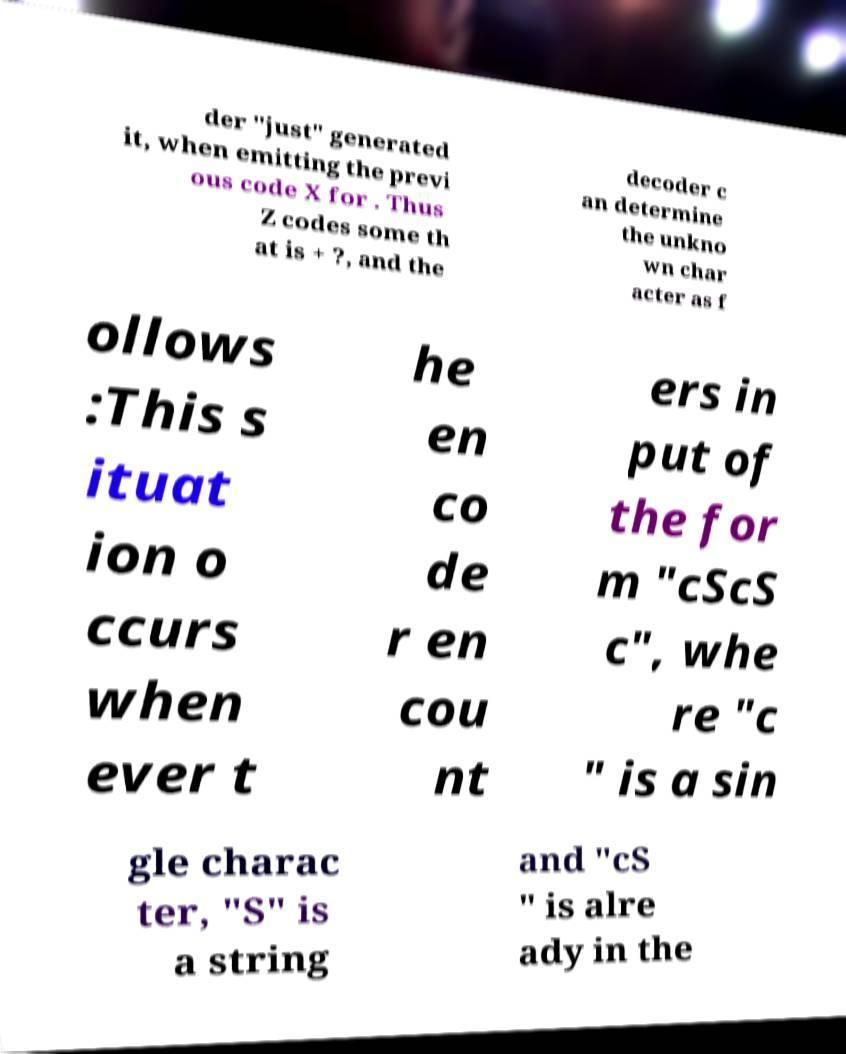Please identify and transcribe the text found in this image. der "just" generated it, when emitting the previ ous code X for . Thus Z codes some th at is + ?, and the decoder c an determine the unkno wn char acter as f ollows :This s ituat ion o ccurs when ever t he en co de r en cou nt ers in put of the for m "cScS c", whe re "c " is a sin gle charac ter, "S" is a string and "cS " is alre ady in the 